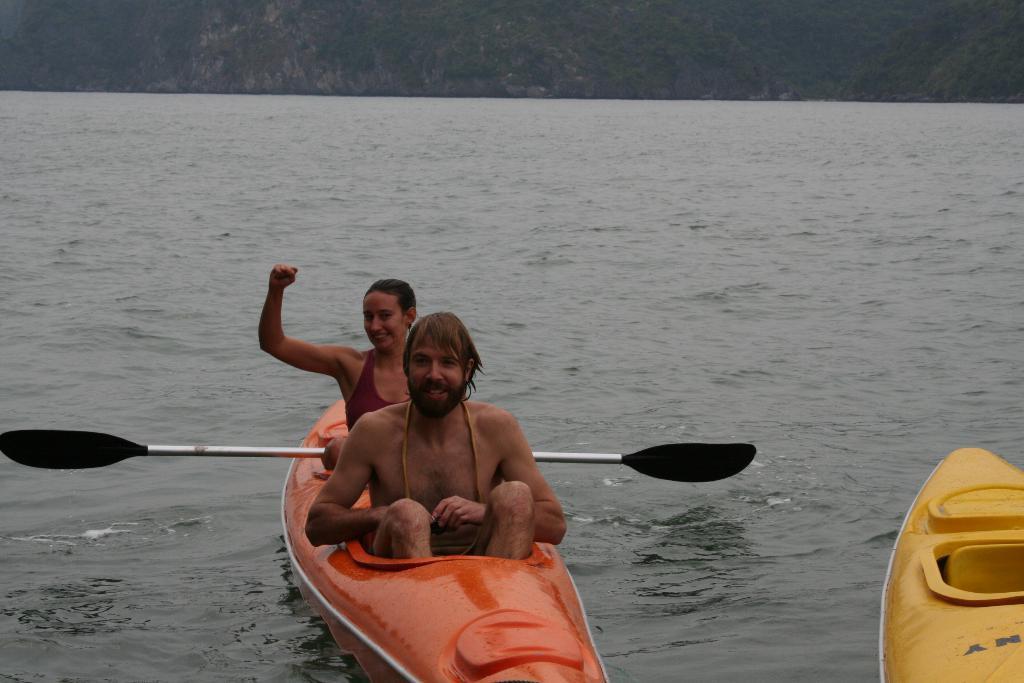Describe this image in one or two sentences. In this image there are boats on the water. In the center there is a man and a woman sitting on the boat. The woman is holding a paddle in her hand. There is the water in the image. At the top there is the sky. 